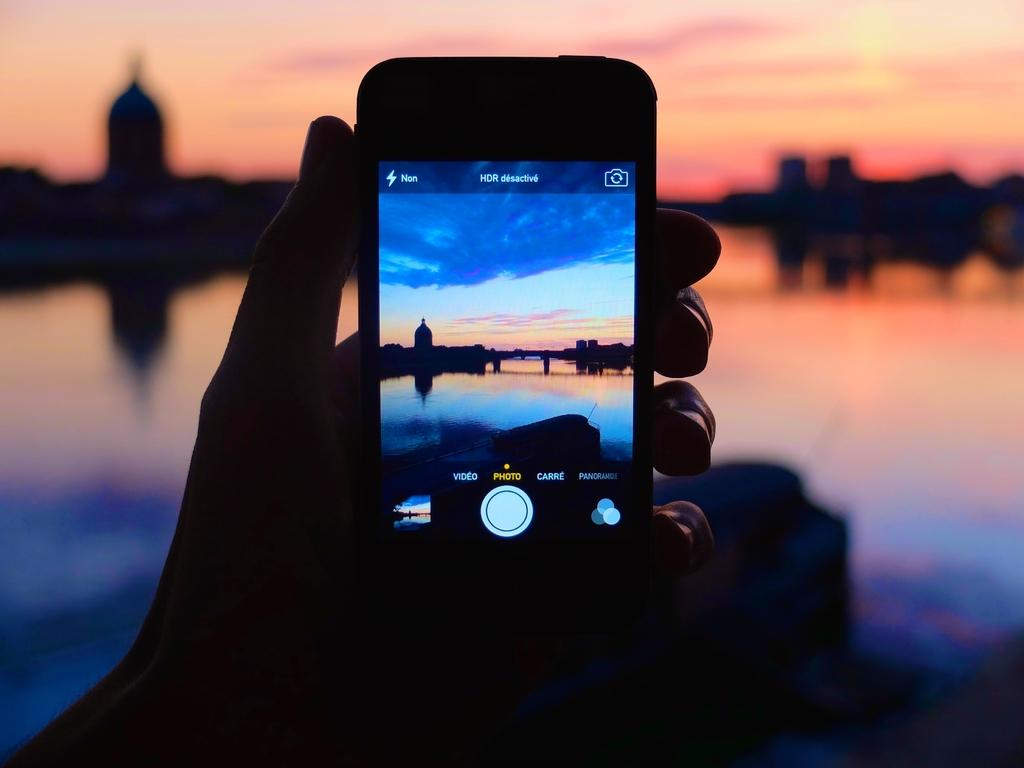What is the person's hand holding in the image? The person's hand is holding a mobile phone in the image. What can be seen on the mobile phone's display? The mobile phone's display shows water, a tower building, and the sky. How is the image of the mobile phone's display presented in the image? The image of the mobile phone's display is slightly blurred. What type of quartz can be seen on the farm in the image? There is no quartz or farm present in the image; it features a person's hand holding a mobile phone with a blurred display. 